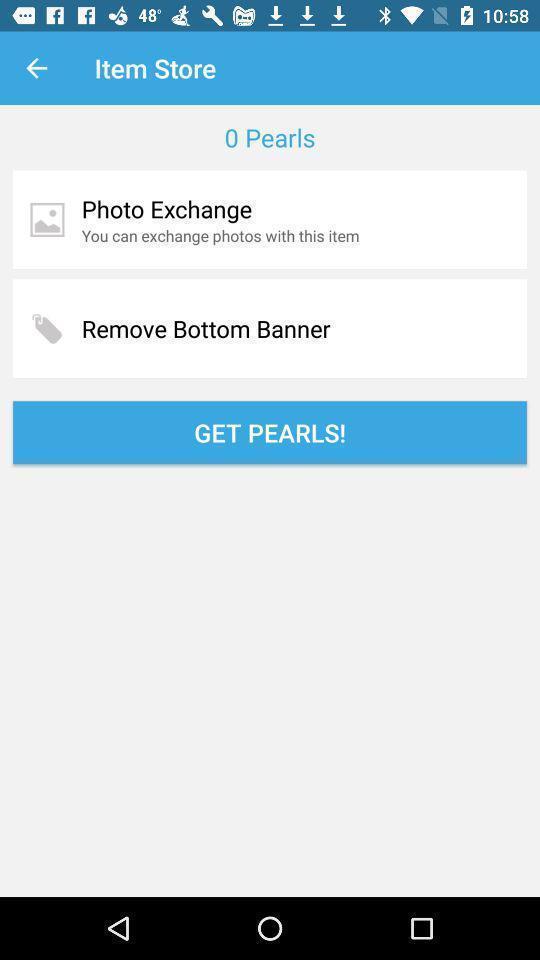Tell me about the visual elements in this screen capture. Page showing different options on an app. 